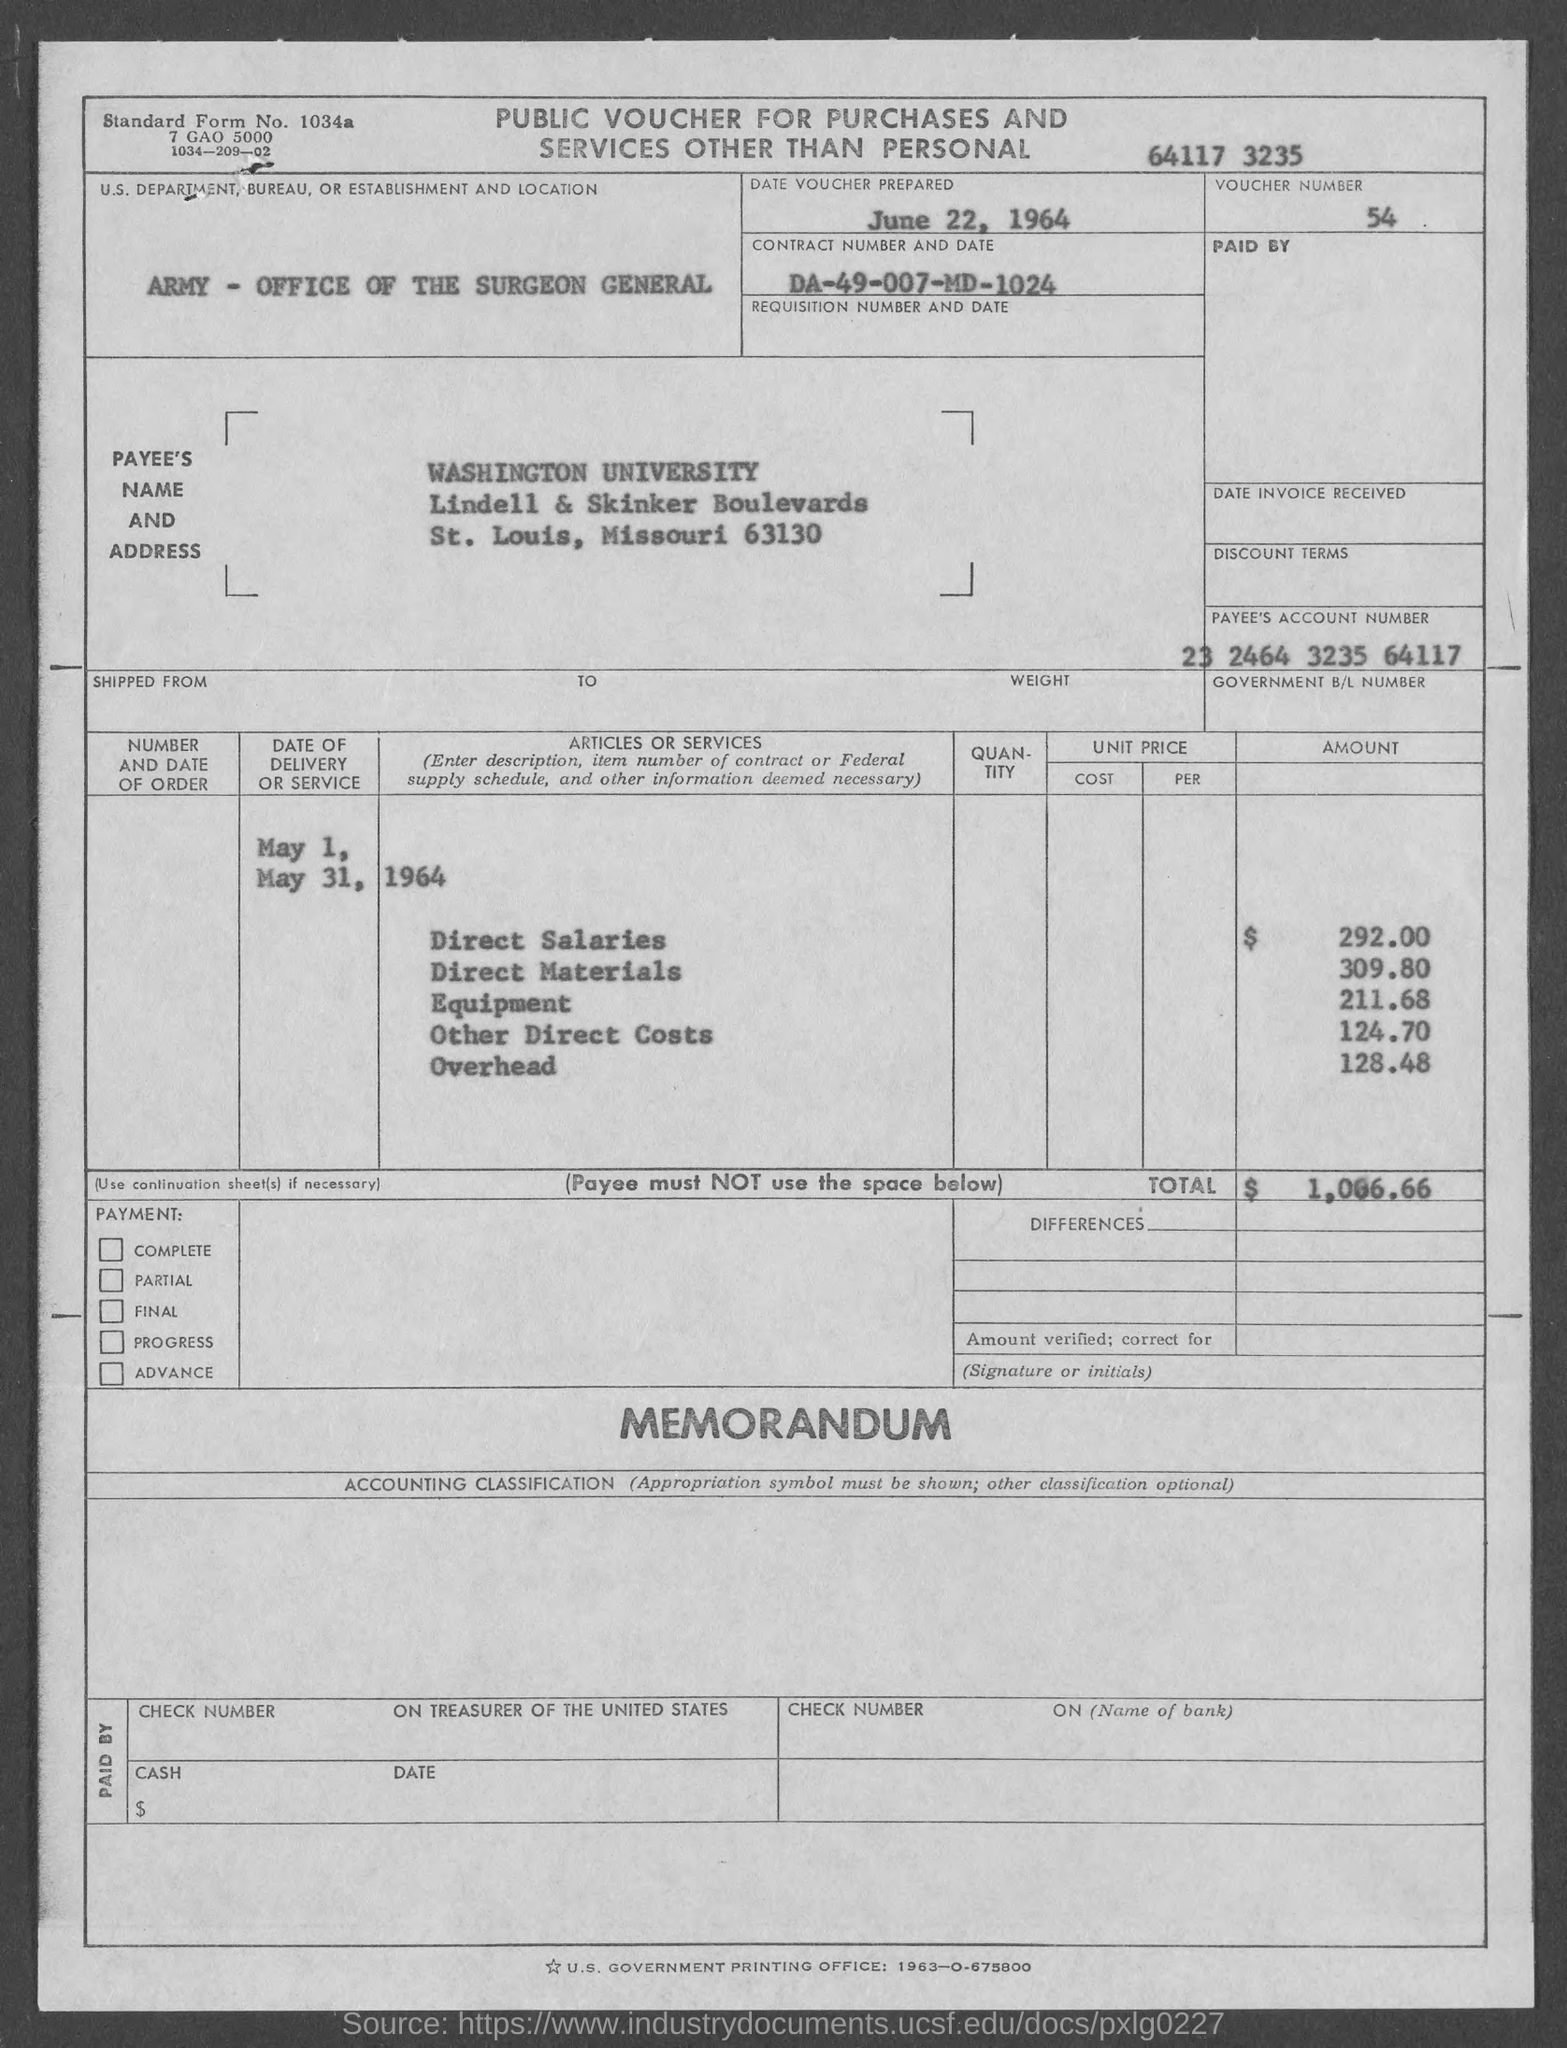What is the voucher number ?
Keep it short and to the point. 54. What is the standard form no.?
Provide a succinct answer. 1034a. In which state is washington university located ?
Keep it short and to the point. Missouri. What is the contract number ?
Offer a terse response. DA-49-007-MD-1024. What is the us. department, bureau, or establishment in voucher?
Make the answer very short. Army- Office of the Surgeon General. What is the payee's account number ?
Your answer should be very brief. 23 2464 3235 64117. What is the total amount ?
Ensure brevity in your answer.  $1,066.66. When is the date voucher prepared ?
Offer a very short reply. June 22, 1964. 